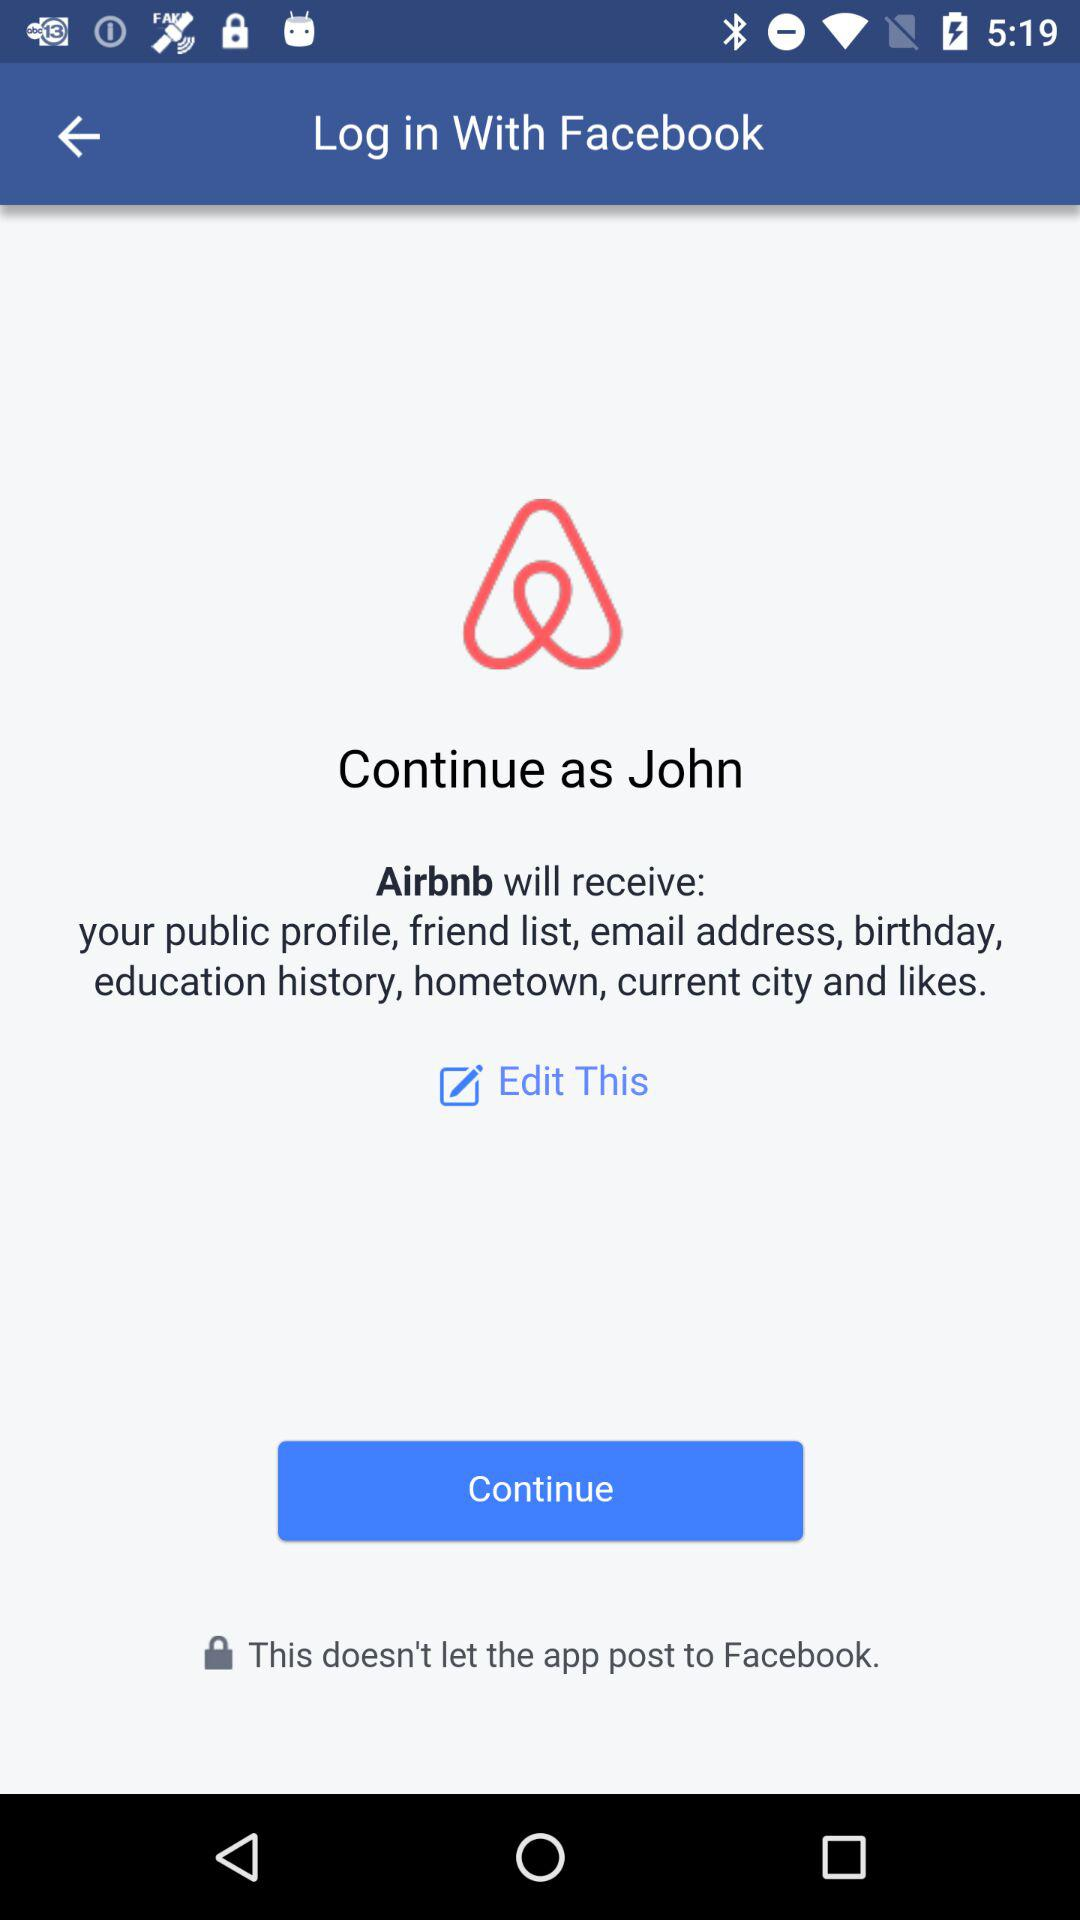Through what account can logging in be done? Logging in can be done through "Facebook" account. 